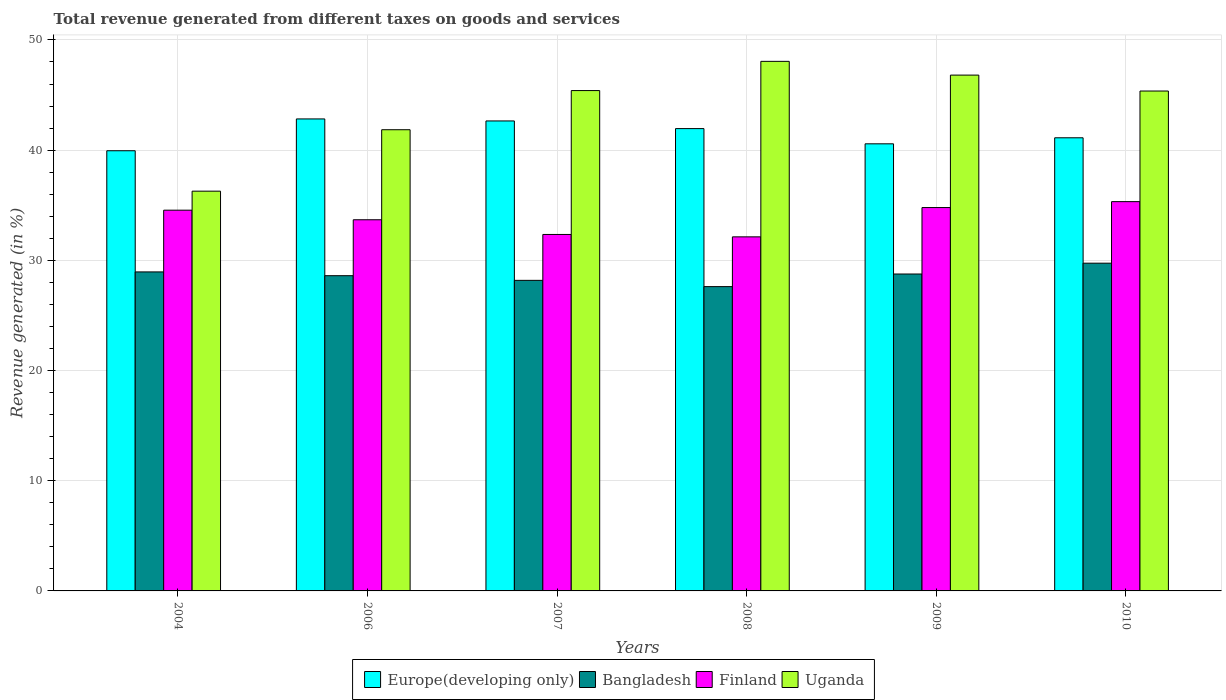How many different coloured bars are there?
Provide a succinct answer. 4. How many groups of bars are there?
Offer a very short reply. 6. Are the number of bars per tick equal to the number of legend labels?
Give a very brief answer. Yes. What is the label of the 5th group of bars from the left?
Your response must be concise. 2009. In how many cases, is the number of bars for a given year not equal to the number of legend labels?
Make the answer very short. 0. What is the total revenue generated in Europe(developing only) in 2010?
Provide a short and direct response. 41.12. Across all years, what is the maximum total revenue generated in Bangladesh?
Give a very brief answer. 29.74. Across all years, what is the minimum total revenue generated in Bangladesh?
Your answer should be very brief. 27.61. In which year was the total revenue generated in Uganda maximum?
Make the answer very short. 2008. What is the total total revenue generated in Europe(developing only) in the graph?
Your answer should be compact. 249.07. What is the difference between the total revenue generated in Uganda in 2004 and that in 2010?
Keep it short and to the point. -9.09. What is the difference between the total revenue generated in Bangladesh in 2010 and the total revenue generated in Europe(developing only) in 2006?
Your answer should be very brief. -13.09. What is the average total revenue generated in Europe(developing only) per year?
Ensure brevity in your answer.  41.51. In the year 2010, what is the difference between the total revenue generated in Bangladesh and total revenue generated in Europe(developing only)?
Ensure brevity in your answer.  -11.38. What is the ratio of the total revenue generated in Europe(developing only) in 2004 to that in 2010?
Your answer should be very brief. 0.97. What is the difference between the highest and the second highest total revenue generated in Uganda?
Ensure brevity in your answer.  1.25. What is the difference between the highest and the lowest total revenue generated in Europe(developing only)?
Keep it short and to the point. 2.89. Is the sum of the total revenue generated in Bangladesh in 2004 and 2008 greater than the maximum total revenue generated in Uganda across all years?
Give a very brief answer. Yes. Is it the case that in every year, the sum of the total revenue generated in Bangladesh and total revenue generated in Finland is greater than the sum of total revenue generated in Europe(developing only) and total revenue generated in Uganda?
Ensure brevity in your answer.  No. What does the 2nd bar from the left in 2007 represents?
Offer a very short reply. Bangladesh. What does the 1st bar from the right in 2008 represents?
Keep it short and to the point. Uganda. Is it the case that in every year, the sum of the total revenue generated in Europe(developing only) and total revenue generated in Bangladesh is greater than the total revenue generated in Uganda?
Make the answer very short. Yes. How many bars are there?
Your answer should be very brief. 24. How many years are there in the graph?
Your answer should be compact. 6. Does the graph contain any zero values?
Keep it short and to the point. No. Does the graph contain grids?
Ensure brevity in your answer.  Yes. What is the title of the graph?
Provide a short and direct response. Total revenue generated from different taxes on goods and services. What is the label or title of the Y-axis?
Offer a terse response. Revenue generated (in %). What is the Revenue generated (in %) of Europe(developing only) in 2004?
Your answer should be very brief. 39.94. What is the Revenue generated (in %) in Bangladesh in 2004?
Give a very brief answer. 28.95. What is the Revenue generated (in %) of Finland in 2004?
Offer a very short reply. 34.55. What is the Revenue generated (in %) in Uganda in 2004?
Keep it short and to the point. 36.28. What is the Revenue generated (in %) in Europe(developing only) in 2006?
Ensure brevity in your answer.  42.83. What is the Revenue generated (in %) of Bangladesh in 2006?
Provide a short and direct response. 28.61. What is the Revenue generated (in %) of Finland in 2006?
Offer a very short reply. 33.68. What is the Revenue generated (in %) of Uganda in 2006?
Offer a terse response. 41.85. What is the Revenue generated (in %) in Europe(developing only) in 2007?
Your response must be concise. 42.65. What is the Revenue generated (in %) of Bangladesh in 2007?
Your answer should be compact. 28.18. What is the Revenue generated (in %) of Finland in 2007?
Offer a very short reply. 32.35. What is the Revenue generated (in %) in Uganda in 2007?
Offer a very short reply. 45.4. What is the Revenue generated (in %) of Europe(developing only) in 2008?
Offer a terse response. 41.95. What is the Revenue generated (in %) of Bangladesh in 2008?
Provide a short and direct response. 27.61. What is the Revenue generated (in %) in Finland in 2008?
Offer a terse response. 32.13. What is the Revenue generated (in %) in Uganda in 2008?
Keep it short and to the point. 48.06. What is the Revenue generated (in %) in Europe(developing only) in 2009?
Provide a succinct answer. 40.57. What is the Revenue generated (in %) in Bangladesh in 2009?
Ensure brevity in your answer.  28.76. What is the Revenue generated (in %) of Finland in 2009?
Your response must be concise. 34.79. What is the Revenue generated (in %) of Uganda in 2009?
Provide a succinct answer. 46.81. What is the Revenue generated (in %) of Europe(developing only) in 2010?
Provide a succinct answer. 41.12. What is the Revenue generated (in %) in Bangladesh in 2010?
Your answer should be compact. 29.74. What is the Revenue generated (in %) in Finland in 2010?
Offer a terse response. 35.33. What is the Revenue generated (in %) in Uganda in 2010?
Provide a succinct answer. 45.36. Across all years, what is the maximum Revenue generated (in %) in Europe(developing only)?
Provide a short and direct response. 42.83. Across all years, what is the maximum Revenue generated (in %) of Bangladesh?
Offer a very short reply. 29.74. Across all years, what is the maximum Revenue generated (in %) in Finland?
Provide a succinct answer. 35.33. Across all years, what is the maximum Revenue generated (in %) in Uganda?
Your answer should be very brief. 48.06. Across all years, what is the minimum Revenue generated (in %) in Europe(developing only)?
Ensure brevity in your answer.  39.94. Across all years, what is the minimum Revenue generated (in %) in Bangladesh?
Ensure brevity in your answer.  27.61. Across all years, what is the minimum Revenue generated (in %) in Finland?
Your answer should be very brief. 32.13. Across all years, what is the minimum Revenue generated (in %) of Uganda?
Offer a terse response. 36.28. What is the total Revenue generated (in %) of Europe(developing only) in the graph?
Give a very brief answer. 249.07. What is the total Revenue generated (in %) in Bangladesh in the graph?
Ensure brevity in your answer.  171.85. What is the total Revenue generated (in %) in Finland in the graph?
Provide a succinct answer. 202.82. What is the total Revenue generated (in %) of Uganda in the graph?
Give a very brief answer. 263.76. What is the difference between the Revenue generated (in %) in Europe(developing only) in 2004 and that in 2006?
Your response must be concise. -2.89. What is the difference between the Revenue generated (in %) in Bangladesh in 2004 and that in 2006?
Your answer should be very brief. 0.34. What is the difference between the Revenue generated (in %) of Finland in 2004 and that in 2006?
Your answer should be very brief. 0.87. What is the difference between the Revenue generated (in %) in Uganda in 2004 and that in 2006?
Offer a terse response. -5.58. What is the difference between the Revenue generated (in %) of Europe(developing only) in 2004 and that in 2007?
Provide a succinct answer. -2.7. What is the difference between the Revenue generated (in %) of Bangladesh in 2004 and that in 2007?
Offer a terse response. 0.77. What is the difference between the Revenue generated (in %) of Finland in 2004 and that in 2007?
Your response must be concise. 2.2. What is the difference between the Revenue generated (in %) of Uganda in 2004 and that in 2007?
Provide a succinct answer. -9.13. What is the difference between the Revenue generated (in %) of Europe(developing only) in 2004 and that in 2008?
Provide a succinct answer. -2.01. What is the difference between the Revenue generated (in %) in Bangladesh in 2004 and that in 2008?
Give a very brief answer. 1.33. What is the difference between the Revenue generated (in %) in Finland in 2004 and that in 2008?
Provide a succinct answer. 2.42. What is the difference between the Revenue generated (in %) of Uganda in 2004 and that in 2008?
Keep it short and to the point. -11.78. What is the difference between the Revenue generated (in %) of Europe(developing only) in 2004 and that in 2009?
Give a very brief answer. -0.63. What is the difference between the Revenue generated (in %) in Bangladesh in 2004 and that in 2009?
Make the answer very short. 0.19. What is the difference between the Revenue generated (in %) of Finland in 2004 and that in 2009?
Give a very brief answer. -0.24. What is the difference between the Revenue generated (in %) of Uganda in 2004 and that in 2009?
Your answer should be compact. -10.53. What is the difference between the Revenue generated (in %) of Europe(developing only) in 2004 and that in 2010?
Offer a very short reply. -1.18. What is the difference between the Revenue generated (in %) of Bangladesh in 2004 and that in 2010?
Give a very brief answer. -0.79. What is the difference between the Revenue generated (in %) in Finland in 2004 and that in 2010?
Your response must be concise. -0.78. What is the difference between the Revenue generated (in %) of Uganda in 2004 and that in 2010?
Offer a terse response. -9.09. What is the difference between the Revenue generated (in %) in Europe(developing only) in 2006 and that in 2007?
Your response must be concise. 0.18. What is the difference between the Revenue generated (in %) of Bangladesh in 2006 and that in 2007?
Offer a terse response. 0.42. What is the difference between the Revenue generated (in %) in Finland in 2006 and that in 2007?
Provide a succinct answer. 1.33. What is the difference between the Revenue generated (in %) in Uganda in 2006 and that in 2007?
Make the answer very short. -3.55. What is the difference between the Revenue generated (in %) of Europe(developing only) in 2006 and that in 2008?
Give a very brief answer. 0.88. What is the difference between the Revenue generated (in %) of Bangladesh in 2006 and that in 2008?
Your response must be concise. 0.99. What is the difference between the Revenue generated (in %) in Finland in 2006 and that in 2008?
Offer a very short reply. 1.55. What is the difference between the Revenue generated (in %) of Uganda in 2006 and that in 2008?
Your answer should be compact. -6.2. What is the difference between the Revenue generated (in %) in Europe(developing only) in 2006 and that in 2009?
Keep it short and to the point. 2.26. What is the difference between the Revenue generated (in %) in Bangladesh in 2006 and that in 2009?
Keep it short and to the point. -0.15. What is the difference between the Revenue generated (in %) of Finland in 2006 and that in 2009?
Ensure brevity in your answer.  -1.11. What is the difference between the Revenue generated (in %) in Uganda in 2006 and that in 2009?
Provide a short and direct response. -4.96. What is the difference between the Revenue generated (in %) in Europe(developing only) in 2006 and that in 2010?
Give a very brief answer. 1.71. What is the difference between the Revenue generated (in %) of Bangladesh in 2006 and that in 2010?
Give a very brief answer. -1.14. What is the difference between the Revenue generated (in %) in Finland in 2006 and that in 2010?
Your response must be concise. -1.64. What is the difference between the Revenue generated (in %) of Uganda in 2006 and that in 2010?
Your answer should be very brief. -3.51. What is the difference between the Revenue generated (in %) of Europe(developing only) in 2007 and that in 2008?
Give a very brief answer. 0.69. What is the difference between the Revenue generated (in %) in Bangladesh in 2007 and that in 2008?
Offer a terse response. 0.57. What is the difference between the Revenue generated (in %) in Finland in 2007 and that in 2008?
Your answer should be compact. 0.22. What is the difference between the Revenue generated (in %) of Uganda in 2007 and that in 2008?
Your answer should be compact. -2.65. What is the difference between the Revenue generated (in %) of Europe(developing only) in 2007 and that in 2009?
Offer a terse response. 2.08. What is the difference between the Revenue generated (in %) of Bangladesh in 2007 and that in 2009?
Your response must be concise. -0.58. What is the difference between the Revenue generated (in %) in Finland in 2007 and that in 2009?
Your answer should be very brief. -2.44. What is the difference between the Revenue generated (in %) of Uganda in 2007 and that in 2009?
Your answer should be compact. -1.4. What is the difference between the Revenue generated (in %) of Europe(developing only) in 2007 and that in 2010?
Make the answer very short. 1.53. What is the difference between the Revenue generated (in %) of Bangladesh in 2007 and that in 2010?
Provide a short and direct response. -1.56. What is the difference between the Revenue generated (in %) of Finland in 2007 and that in 2010?
Your answer should be compact. -2.98. What is the difference between the Revenue generated (in %) of Uganda in 2007 and that in 2010?
Keep it short and to the point. 0.04. What is the difference between the Revenue generated (in %) of Europe(developing only) in 2008 and that in 2009?
Keep it short and to the point. 1.38. What is the difference between the Revenue generated (in %) in Bangladesh in 2008 and that in 2009?
Make the answer very short. -1.14. What is the difference between the Revenue generated (in %) in Finland in 2008 and that in 2009?
Provide a succinct answer. -2.66. What is the difference between the Revenue generated (in %) of Uganda in 2008 and that in 2009?
Provide a short and direct response. 1.25. What is the difference between the Revenue generated (in %) in Europe(developing only) in 2008 and that in 2010?
Make the answer very short. 0.83. What is the difference between the Revenue generated (in %) of Bangladesh in 2008 and that in 2010?
Offer a very short reply. -2.13. What is the difference between the Revenue generated (in %) in Finland in 2008 and that in 2010?
Your answer should be compact. -3.2. What is the difference between the Revenue generated (in %) in Uganda in 2008 and that in 2010?
Ensure brevity in your answer.  2.69. What is the difference between the Revenue generated (in %) of Europe(developing only) in 2009 and that in 2010?
Keep it short and to the point. -0.55. What is the difference between the Revenue generated (in %) in Bangladesh in 2009 and that in 2010?
Provide a short and direct response. -0.98. What is the difference between the Revenue generated (in %) in Finland in 2009 and that in 2010?
Make the answer very short. -0.54. What is the difference between the Revenue generated (in %) of Uganda in 2009 and that in 2010?
Your answer should be very brief. 1.44. What is the difference between the Revenue generated (in %) of Europe(developing only) in 2004 and the Revenue generated (in %) of Bangladesh in 2006?
Provide a short and direct response. 11.34. What is the difference between the Revenue generated (in %) of Europe(developing only) in 2004 and the Revenue generated (in %) of Finland in 2006?
Provide a short and direct response. 6.26. What is the difference between the Revenue generated (in %) of Europe(developing only) in 2004 and the Revenue generated (in %) of Uganda in 2006?
Ensure brevity in your answer.  -1.91. What is the difference between the Revenue generated (in %) in Bangladesh in 2004 and the Revenue generated (in %) in Finland in 2006?
Make the answer very short. -4.73. What is the difference between the Revenue generated (in %) of Bangladesh in 2004 and the Revenue generated (in %) of Uganda in 2006?
Your answer should be compact. -12.9. What is the difference between the Revenue generated (in %) of Finland in 2004 and the Revenue generated (in %) of Uganda in 2006?
Your answer should be compact. -7.3. What is the difference between the Revenue generated (in %) in Europe(developing only) in 2004 and the Revenue generated (in %) in Bangladesh in 2007?
Offer a terse response. 11.76. What is the difference between the Revenue generated (in %) of Europe(developing only) in 2004 and the Revenue generated (in %) of Finland in 2007?
Offer a very short reply. 7.6. What is the difference between the Revenue generated (in %) in Europe(developing only) in 2004 and the Revenue generated (in %) in Uganda in 2007?
Offer a terse response. -5.46. What is the difference between the Revenue generated (in %) of Bangladesh in 2004 and the Revenue generated (in %) of Finland in 2007?
Provide a short and direct response. -3.4. What is the difference between the Revenue generated (in %) in Bangladesh in 2004 and the Revenue generated (in %) in Uganda in 2007?
Your answer should be compact. -16.46. What is the difference between the Revenue generated (in %) in Finland in 2004 and the Revenue generated (in %) in Uganda in 2007?
Offer a terse response. -10.85. What is the difference between the Revenue generated (in %) in Europe(developing only) in 2004 and the Revenue generated (in %) in Bangladesh in 2008?
Make the answer very short. 12.33. What is the difference between the Revenue generated (in %) in Europe(developing only) in 2004 and the Revenue generated (in %) in Finland in 2008?
Your response must be concise. 7.81. What is the difference between the Revenue generated (in %) in Europe(developing only) in 2004 and the Revenue generated (in %) in Uganda in 2008?
Provide a succinct answer. -8.11. What is the difference between the Revenue generated (in %) of Bangladesh in 2004 and the Revenue generated (in %) of Finland in 2008?
Keep it short and to the point. -3.18. What is the difference between the Revenue generated (in %) in Bangladesh in 2004 and the Revenue generated (in %) in Uganda in 2008?
Give a very brief answer. -19.11. What is the difference between the Revenue generated (in %) of Finland in 2004 and the Revenue generated (in %) of Uganda in 2008?
Make the answer very short. -13.5. What is the difference between the Revenue generated (in %) of Europe(developing only) in 2004 and the Revenue generated (in %) of Bangladesh in 2009?
Your answer should be very brief. 11.19. What is the difference between the Revenue generated (in %) of Europe(developing only) in 2004 and the Revenue generated (in %) of Finland in 2009?
Offer a very short reply. 5.16. What is the difference between the Revenue generated (in %) of Europe(developing only) in 2004 and the Revenue generated (in %) of Uganda in 2009?
Provide a succinct answer. -6.86. What is the difference between the Revenue generated (in %) of Bangladesh in 2004 and the Revenue generated (in %) of Finland in 2009?
Provide a short and direct response. -5.84. What is the difference between the Revenue generated (in %) in Bangladesh in 2004 and the Revenue generated (in %) in Uganda in 2009?
Offer a very short reply. -17.86. What is the difference between the Revenue generated (in %) of Finland in 2004 and the Revenue generated (in %) of Uganda in 2009?
Keep it short and to the point. -12.26. What is the difference between the Revenue generated (in %) of Europe(developing only) in 2004 and the Revenue generated (in %) of Bangladesh in 2010?
Your answer should be very brief. 10.2. What is the difference between the Revenue generated (in %) in Europe(developing only) in 2004 and the Revenue generated (in %) in Finland in 2010?
Your response must be concise. 4.62. What is the difference between the Revenue generated (in %) in Europe(developing only) in 2004 and the Revenue generated (in %) in Uganda in 2010?
Provide a succinct answer. -5.42. What is the difference between the Revenue generated (in %) in Bangladesh in 2004 and the Revenue generated (in %) in Finland in 2010?
Offer a terse response. -6.38. What is the difference between the Revenue generated (in %) of Bangladesh in 2004 and the Revenue generated (in %) of Uganda in 2010?
Offer a terse response. -16.42. What is the difference between the Revenue generated (in %) of Finland in 2004 and the Revenue generated (in %) of Uganda in 2010?
Ensure brevity in your answer.  -10.81. What is the difference between the Revenue generated (in %) of Europe(developing only) in 2006 and the Revenue generated (in %) of Bangladesh in 2007?
Make the answer very short. 14.65. What is the difference between the Revenue generated (in %) of Europe(developing only) in 2006 and the Revenue generated (in %) of Finland in 2007?
Provide a short and direct response. 10.48. What is the difference between the Revenue generated (in %) in Europe(developing only) in 2006 and the Revenue generated (in %) in Uganda in 2007?
Your answer should be very brief. -2.57. What is the difference between the Revenue generated (in %) of Bangladesh in 2006 and the Revenue generated (in %) of Finland in 2007?
Offer a terse response. -3.74. What is the difference between the Revenue generated (in %) of Bangladesh in 2006 and the Revenue generated (in %) of Uganda in 2007?
Your response must be concise. -16.8. What is the difference between the Revenue generated (in %) in Finland in 2006 and the Revenue generated (in %) in Uganda in 2007?
Offer a very short reply. -11.72. What is the difference between the Revenue generated (in %) of Europe(developing only) in 2006 and the Revenue generated (in %) of Bangladesh in 2008?
Your response must be concise. 15.22. What is the difference between the Revenue generated (in %) in Europe(developing only) in 2006 and the Revenue generated (in %) in Finland in 2008?
Provide a short and direct response. 10.7. What is the difference between the Revenue generated (in %) in Europe(developing only) in 2006 and the Revenue generated (in %) in Uganda in 2008?
Offer a very short reply. -5.23. What is the difference between the Revenue generated (in %) in Bangladesh in 2006 and the Revenue generated (in %) in Finland in 2008?
Make the answer very short. -3.52. What is the difference between the Revenue generated (in %) of Bangladesh in 2006 and the Revenue generated (in %) of Uganda in 2008?
Your answer should be compact. -19.45. What is the difference between the Revenue generated (in %) of Finland in 2006 and the Revenue generated (in %) of Uganda in 2008?
Offer a terse response. -14.37. What is the difference between the Revenue generated (in %) of Europe(developing only) in 2006 and the Revenue generated (in %) of Bangladesh in 2009?
Your answer should be very brief. 14.07. What is the difference between the Revenue generated (in %) in Europe(developing only) in 2006 and the Revenue generated (in %) in Finland in 2009?
Ensure brevity in your answer.  8.04. What is the difference between the Revenue generated (in %) in Europe(developing only) in 2006 and the Revenue generated (in %) in Uganda in 2009?
Your response must be concise. -3.98. What is the difference between the Revenue generated (in %) of Bangladesh in 2006 and the Revenue generated (in %) of Finland in 2009?
Keep it short and to the point. -6.18. What is the difference between the Revenue generated (in %) in Bangladesh in 2006 and the Revenue generated (in %) in Uganda in 2009?
Keep it short and to the point. -18.2. What is the difference between the Revenue generated (in %) of Finland in 2006 and the Revenue generated (in %) of Uganda in 2009?
Provide a short and direct response. -13.13. What is the difference between the Revenue generated (in %) of Europe(developing only) in 2006 and the Revenue generated (in %) of Bangladesh in 2010?
Offer a very short reply. 13.09. What is the difference between the Revenue generated (in %) of Europe(developing only) in 2006 and the Revenue generated (in %) of Finland in 2010?
Provide a succinct answer. 7.5. What is the difference between the Revenue generated (in %) of Europe(developing only) in 2006 and the Revenue generated (in %) of Uganda in 2010?
Provide a succinct answer. -2.53. What is the difference between the Revenue generated (in %) in Bangladesh in 2006 and the Revenue generated (in %) in Finland in 2010?
Ensure brevity in your answer.  -6.72. What is the difference between the Revenue generated (in %) in Bangladesh in 2006 and the Revenue generated (in %) in Uganda in 2010?
Your response must be concise. -16.76. What is the difference between the Revenue generated (in %) of Finland in 2006 and the Revenue generated (in %) of Uganda in 2010?
Offer a very short reply. -11.68. What is the difference between the Revenue generated (in %) in Europe(developing only) in 2007 and the Revenue generated (in %) in Bangladesh in 2008?
Your answer should be very brief. 15.03. What is the difference between the Revenue generated (in %) of Europe(developing only) in 2007 and the Revenue generated (in %) of Finland in 2008?
Ensure brevity in your answer.  10.52. What is the difference between the Revenue generated (in %) of Europe(developing only) in 2007 and the Revenue generated (in %) of Uganda in 2008?
Offer a very short reply. -5.41. What is the difference between the Revenue generated (in %) in Bangladesh in 2007 and the Revenue generated (in %) in Finland in 2008?
Keep it short and to the point. -3.95. What is the difference between the Revenue generated (in %) of Bangladesh in 2007 and the Revenue generated (in %) of Uganda in 2008?
Give a very brief answer. -19.87. What is the difference between the Revenue generated (in %) in Finland in 2007 and the Revenue generated (in %) in Uganda in 2008?
Your response must be concise. -15.71. What is the difference between the Revenue generated (in %) in Europe(developing only) in 2007 and the Revenue generated (in %) in Bangladesh in 2009?
Offer a terse response. 13.89. What is the difference between the Revenue generated (in %) of Europe(developing only) in 2007 and the Revenue generated (in %) of Finland in 2009?
Keep it short and to the point. 7.86. What is the difference between the Revenue generated (in %) of Europe(developing only) in 2007 and the Revenue generated (in %) of Uganda in 2009?
Ensure brevity in your answer.  -4.16. What is the difference between the Revenue generated (in %) in Bangladesh in 2007 and the Revenue generated (in %) in Finland in 2009?
Make the answer very short. -6.61. What is the difference between the Revenue generated (in %) in Bangladesh in 2007 and the Revenue generated (in %) in Uganda in 2009?
Your response must be concise. -18.63. What is the difference between the Revenue generated (in %) of Finland in 2007 and the Revenue generated (in %) of Uganda in 2009?
Ensure brevity in your answer.  -14.46. What is the difference between the Revenue generated (in %) in Europe(developing only) in 2007 and the Revenue generated (in %) in Bangladesh in 2010?
Your response must be concise. 12.91. What is the difference between the Revenue generated (in %) of Europe(developing only) in 2007 and the Revenue generated (in %) of Finland in 2010?
Provide a short and direct response. 7.32. What is the difference between the Revenue generated (in %) of Europe(developing only) in 2007 and the Revenue generated (in %) of Uganda in 2010?
Ensure brevity in your answer.  -2.72. What is the difference between the Revenue generated (in %) of Bangladesh in 2007 and the Revenue generated (in %) of Finland in 2010?
Your answer should be very brief. -7.14. What is the difference between the Revenue generated (in %) of Bangladesh in 2007 and the Revenue generated (in %) of Uganda in 2010?
Offer a terse response. -17.18. What is the difference between the Revenue generated (in %) in Finland in 2007 and the Revenue generated (in %) in Uganda in 2010?
Give a very brief answer. -13.02. What is the difference between the Revenue generated (in %) in Europe(developing only) in 2008 and the Revenue generated (in %) in Bangladesh in 2009?
Ensure brevity in your answer.  13.2. What is the difference between the Revenue generated (in %) of Europe(developing only) in 2008 and the Revenue generated (in %) of Finland in 2009?
Make the answer very short. 7.17. What is the difference between the Revenue generated (in %) in Europe(developing only) in 2008 and the Revenue generated (in %) in Uganda in 2009?
Provide a short and direct response. -4.85. What is the difference between the Revenue generated (in %) in Bangladesh in 2008 and the Revenue generated (in %) in Finland in 2009?
Offer a very short reply. -7.17. What is the difference between the Revenue generated (in %) in Bangladesh in 2008 and the Revenue generated (in %) in Uganda in 2009?
Offer a very short reply. -19.19. What is the difference between the Revenue generated (in %) of Finland in 2008 and the Revenue generated (in %) of Uganda in 2009?
Your response must be concise. -14.68. What is the difference between the Revenue generated (in %) of Europe(developing only) in 2008 and the Revenue generated (in %) of Bangladesh in 2010?
Provide a short and direct response. 12.21. What is the difference between the Revenue generated (in %) in Europe(developing only) in 2008 and the Revenue generated (in %) in Finland in 2010?
Your response must be concise. 6.63. What is the difference between the Revenue generated (in %) of Europe(developing only) in 2008 and the Revenue generated (in %) of Uganda in 2010?
Your response must be concise. -3.41. What is the difference between the Revenue generated (in %) of Bangladesh in 2008 and the Revenue generated (in %) of Finland in 2010?
Your response must be concise. -7.71. What is the difference between the Revenue generated (in %) in Bangladesh in 2008 and the Revenue generated (in %) in Uganda in 2010?
Your response must be concise. -17.75. What is the difference between the Revenue generated (in %) of Finland in 2008 and the Revenue generated (in %) of Uganda in 2010?
Your response must be concise. -13.23. What is the difference between the Revenue generated (in %) in Europe(developing only) in 2009 and the Revenue generated (in %) in Bangladesh in 2010?
Keep it short and to the point. 10.83. What is the difference between the Revenue generated (in %) in Europe(developing only) in 2009 and the Revenue generated (in %) in Finland in 2010?
Your answer should be compact. 5.25. What is the difference between the Revenue generated (in %) in Europe(developing only) in 2009 and the Revenue generated (in %) in Uganda in 2010?
Offer a very short reply. -4.79. What is the difference between the Revenue generated (in %) in Bangladesh in 2009 and the Revenue generated (in %) in Finland in 2010?
Keep it short and to the point. -6.57. What is the difference between the Revenue generated (in %) in Bangladesh in 2009 and the Revenue generated (in %) in Uganda in 2010?
Offer a terse response. -16.61. What is the difference between the Revenue generated (in %) in Finland in 2009 and the Revenue generated (in %) in Uganda in 2010?
Offer a very short reply. -10.58. What is the average Revenue generated (in %) of Europe(developing only) per year?
Make the answer very short. 41.51. What is the average Revenue generated (in %) in Bangladesh per year?
Offer a very short reply. 28.64. What is the average Revenue generated (in %) of Finland per year?
Provide a succinct answer. 33.8. What is the average Revenue generated (in %) in Uganda per year?
Your response must be concise. 43.96. In the year 2004, what is the difference between the Revenue generated (in %) of Europe(developing only) and Revenue generated (in %) of Bangladesh?
Your response must be concise. 11. In the year 2004, what is the difference between the Revenue generated (in %) in Europe(developing only) and Revenue generated (in %) in Finland?
Make the answer very short. 5.39. In the year 2004, what is the difference between the Revenue generated (in %) of Europe(developing only) and Revenue generated (in %) of Uganda?
Your answer should be compact. 3.67. In the year 2004, what is the difference between the Revenue generated (in %) of Bangladesh and Revenue generated (in %) of Finland?
Ensure brevity in your answer.  -5.6. In the year 2004, what is the difference between the Revenue generated (in %) of Bangladesh and Revenue generated (in %) of Uganda?
Your response must be concise. -7.33. In the year 2004, what is the difference between the Revenue generated (in %) in Finland and Revenue generated (in %) in Uganda?
Keep it short and to the point. -1.72. In the year 2006, what is the difference between the Revenue generated (in %) of Europe(developing only) and Revenue generated (in %) of Bangladesh?
Offer a terse response. 14.22. In the year 2006, what is the difference between the Revenue generated (in %) of Europe(developing only) and Revenue generated (in %) of Finland?
Keep it short and to the point. 9.15. In the year 2006, what is the difference between the Revenue generated (in %) of Europe(developing only) and Revenue generated (in %) of Uganda?
Offer a terse response. 0.98. In the year 2006, what is the difference between the Revenue generated (in %) of Bangladesh and Revenue generated (in %) of Finland?
Make the answer very short. -5.08. In the year 2006, what is the difference between the Revenue generated (in %) of Bangladesh and Revenue generated (in %) of Uganda?
Ensure brevity in your answer.  -13.25. In the year 2006, what is the difference between the Revenue generated (in %) of Finland and Revenue generated (in %) of Uganda?
Give a very brief answer. -8.17. In the year 2007, what is the difference between the Revenue generated (in %) of Europe(developing only) and Revenue generated (in %) of Bangladesh?
Your answer should be compact. 14.47. In the year 2007, what is the difference between the Revenue generated (in %) of Europe(developing only) and Revenue generated (in %) of Finland?
Offer a very short reply. 10.3. In the year 2007, what is the difference between the Revenue generated (in %) in Europe(developing only) and Revenue generated (in %) in Uganda?
Provide a short and direct response. -2.76. In the year 2007, what is the difference between the Revenue generated (in %) of Bangladesh and Revenue generated (in %) of Finland?
Your answer should be compact. -4.16. In the year 2007, what is the difference between the Revenue generated (in %) of Bangladesh and Revenue generated (in %) of Uganda?
Make the answer very short. -17.22. In the year 2007, what is the difference between the Revenue generated (in %) of Finland and Revenue generated (in %) of Uganda?
Give a very brief answer. -13.06. In the year 2008, what is the difference between the Revenue generated (in %) in Europe(developing only) and Revenue generated (in %) in Bangladesh?
Ensure brevity in your answer.  14.34. In the year 2008, what is the difference between the Revenue generated (in %) in Europe(developing only) and Revenue generated (in %) in Finland?
Give a very brief answer. 9.82. In the year 2008, what is the difference between the Revenue generated (in %) of Europe(developing only) and Revenue generated (in %) of Uganda?
Give a very brief answer. -6.1. In the year 2008, what is the difference between the Revenue generated (in %) in Bangladesh and Revenue generated (in %) in Finland?
Make the answer very short. -4.52. In the year 2008, what is the difference between the Revenue generated (in %) of Bangladesh and Revenue generated (in %) of Uganda?
Provide a short and direct response. -20.44. In the year 2008, what is the difference between the Revenue generated (in %) of Finland and Revenue generated (in %) of Uganda?
Keep it short and to the point. -15.93. In the year 2009, what is the difference between the Revenue generated (in %) in Europe(developing only) and Revenue generated (in %) in Bangladesh?
Offer a very short reply. 11.81. In the year 2009, what is the difference between the Revenue generated (in %) in Europe(developing only) and Revenue generated (in %) in Finland?
Your answer should be very brief. 5.78. In the year 2009, what is the difference between the Revenue generated (in %) in Europe(developing only) and Revenue generated (in %) in Uganda?
Offer a terse response. -6.24. In the year 2009, what is the difference between the Revenue generated (in %) of Bangladesh and Revenue generated (in %) of Finland?
Provide a short and direct response. -6.03. In the year 2009, what is the difference between the Revenue generated (in %) in Bangladesh and Revenue generated (in %) in Uganda?
Your answer should be compact. -18.05. In the year 2009, what is the difference between the Revenue generated (in %) in Finland and Revenue generated (in %) in Uganda?
Ensure brevity in your answer.  -12.02. In the year 2010, what is the difference between the Revenue generated (in %) in Europe(developing only) and Revenue generated (in %) in Bangladesh?
Provide a short and direct response. 11.38. In the year 2010, what is the difference between the Revenue generated (in %) in Europe(developing only) and Revenue generated (in %) in Finland?
Offer a terse response. 5.79. In the year 2010, what is the difference between the Revenue generated (in %) in Europe(developing only) and Revenue generated (in %) in Uganda?
Provide a short and direct response. -4.24. In the year 2010, what is the difference between the Revenue generated (in %) in Bangladesh and Revenue generated (in %) in Finland?
Offer a very short reply. -5.58. In the year 2010, what is the difference between the Revenue generated (in %) in Bangladesh and Revenue generated (in %) in Uganda?
Ensure brevity in your answer.  -15.62. In the year 2010, what is the difference between the Revenue generated (in %) of Finland and Revenue generated (in %) of Uganda?
Offer a very short reply. -10.04. What is the ratio of the Revenue generated (in %) of Europe(developing only) in 2004 to that in 2006?
Keep it short and to the point. 0.93. What is the ratio of the Revenue generated (in %) in Bangladesh in 2004 to that in 2006?
Provide a succinct answer. 1.01. What is the ratio of the Revenue generated (in %) of Finland in 2004 to that in 2006?
Keep it short and to the point. 1.03. What is the ratio of the Revenue generated (in %) in Uganda in 2004 to that in 2006?
Your answer should be very brief. 0.87. What is the ratio of the Revenue generated (in %) in Europe(developing only) in 2004 to that in 2007?
Offer a very short reply. 0.94. What is the ratio of the Revenue generated (in %) in Bangladesh in 2004 to that in 2007?
Your answer should be compact. 1.03. What is the ratio of the Revenue generated (in %) in Finland in 2004 to that in 2007?
Provide a short and direct response. 1.07. What is the ratio of the Revenue generated (in %) of Uganda in 2004 to that in 2007?
Offer a very short reply. 0.8. What is the ratio of the Revenue generated (in %) of Europe(developing only) in 2004 to that in 2008?
Offer a very short reply. 0.95. What is the ratio of the Revenue generated (in %) in Bangladesh in 2004 to that in 2008?
Offer a terse response. 1.05. What is the ratio of the Revenue generated (in %) of Finland in 2004 to that in 2008?
Keep it short and to the point. 1.08. What is the ratio of the Revenue generated (in %) of Uganda in 2004 to that in 2008?
Your answer should be very brief. 0.75. What is the ratio of the Revenue generated (in %) of Europe(developing only) in 2004 to that in 2009?
Offer a terse response. 0.98. What is the ratio of the Revenue generated (in %) of Bangladesh in 2004 to that in 2009?
Ensure brevity in your answer.  1.01. What is the ratio of the Revenue generated (in %) in Finland in 2004 to that in 2009?
Give a very brief answer. 0.99. What is the ratio of the Revenue generated (in %) of Uganda in 2004 to that in 2009?
Your answer should be very brief. 0.78. What is the ratio of the Revenue generated (in %) in Europe(developing only) in 2004 to that in 2010?
Ensure brevity in your answer.  0.97. What is the ratio of the Revenue generated (in %) of Bangladesh in 2004 to that in 2010?
Offer a very short reply. 0.97. What is the ratio of the Revenue generated (in %) of Finland in 2004 to that in 2010?
Provide a succinct answer. 0.98. What is the ratio of the Revenue generated (in %) of Uganda in 2004 to that in 2010?
Your answer should be very brief. 0.8. What is the ratio of the Revenue generated (in %) of Europe(developing only) in 2006 to that in 2007?
Offer a terse response. 1. What is the ratio of the Revenue generated (in %) in Bangladesh in 2006 to that in 2007?
Your response must be concise. 1.01. What is the ratio of the Revenue generated (in %) in Finland in 2006 to that in 2007?
Your answer should be compact. 1.04. What is the ratio of the Revenue generated (in %) in Uganda in 2006 to that in 2007?
Your response must be concise. 0.92. What is the ratio of the Revenue generated (in %) in Europe(developing only) in 2006 to that in 2008?
Provide a short and direct response. 1.02. What is the ratio of the Revenue generated (in %) of Bangladesh in 2006 to that in 2008?
Provide a short and direct response. 1.04. What is the ratio of the Revenue generated (in %) of Finland in 2006 to that in 2008?
Your response must be concise. 1.05. What is the ratio of the Revenue generated (in %) of Uganda in 2006 to that in 2008?
Your answer should be very brief. 0.87. What is the ratio of the Revenue generated (in %) of Europe(developing only) in 2006 to that in 2009?
Provide a short and direct response. 1.06. What is the ratio of the Revenue generated (in %) of Bangladesh in 2006 to that in 2009?
Your response must be concise. 0.99. What is the ratio of the Revenue generated (in %) of Finland in 2006 to that in 2009?
Your response must be concise. 0.97. What is the ratio of the Revenue generated (in %) in Uganda in 2006 to that in 2009?
Provide a short and direct response. 0.89. What is the ratio of the Revenue generated (in %) in Europe(developing only) in 2006 to that in 2010?
Make the answer very short. 1.04. What is the ratio of the Revenue generated (in %) of Bangladesh in 2006 to that in 2010?
Ensure brevity in your answer.  0.96. What is the ratio of the Revenue generated (in %) of Finland in 2006 to that in 2010?
Provide a short and direct response. 0.95. What is the ratio of the Revenue generated (in %) of Uganda in 2006 to that in 2010?
Your response must be concise. 0.92. What is the ratio of the Revenue generated (in %) in Europe(developing only) in 2007 to that in 2008?
Make the answer very short. 1.02. What is the ratio of the Revenue generated (in %) of Bangladesh in 2007 to that in 2008?
Offer a very short reply. 1.02. What is the ratio of the Revenue generated (in %) in Finland in 2007 to that in 2008?
Provide a short and direct response. 1.01. What is the ratio of the Revenue generated (in %) in Uganda in 2007 to that in 2008?
Make the answer very short. 0.94. What is the ratio of the Revenue generated (in %) of Europe(developing only) in 2007 to that in 2009?
Keep it short and to the point. 1.05. What is the ratio of the Revenue generated (in %) in Bangladesh in 2007 to that in 2009?
Give a very brief answer. 0.98. What is the ratio of the Revenue generated (in %) of Finland in 2007 to that in 2009?
Make the answer very short. 0.93. What is the ratio of the Revenue generated (in %) in Uganda in 2007 to that in 2009?
Your answer should be very brief. 0.97. What is the ratio of the Revenue generated (in %) of Europe(developing only) in 2007 to that in 2010?
Offer a terse response. 1.04. What is the ratio of the Revenue generated (in %) of Bangladesh in 2007 to that in 2010?
Keep it short and to the point. 0.95. What is the ratio of the Revenue generated (in %) of Finland in 2007 to that in 2010?
Offer a terse response. 0.92. What is the ratio of the Revenue generated (in %) in Europe(developing only) in 2008 to that in 2009?
Provide a succinct answer. 1.03. What is the ratio of the Revenue generated (in %) of Bangladesh in 2008 to that in 2009?
Give a very brief answer. 0.96. What is the ratio of the Revenue generated (in %) in Finland in 2008 to that in 2009?
Keep it short and to the point. 0.92. What is the ratio of the Revenue generated (in %) in Uganda in 2008 to that in 2009?
Give a very brief answer. 1.03. What is the ratio of the Revenue generated (in %) of Europe(developing only) in 2008 to that in 2010?
Give a very brief answer. 1.02. What is the ratio of the Revenue generated (in %) of Bangladesh in 2008 to that in 2010?
Your answer should be very brief. 0.93. What is the ratio of the Revenue generated (in %) of Finland in 2008 to that in 2010?
Keep it short and to the point. 0.91. What is the ratio of the Revenue generated (in %) of Uganda in 2008 to that in 2010?
Your answer should be very brief. 1.06. What is the ratio of the Revenue generated (in %) of Europe(developing only) in 2009 to that in 2010?
Give a very brief answer. 0.99. What is the ratio of the Revenue generated (in %) in Bangladesh in 2009 to that in 2010?
Offer a very short reply. 0.97. What is the ratio of the Revenue generated (in %) of Finland in 2009 to that in 2010?
Offer a very short reply. 0.98. What is the ratio of the Revenue generated (in %) in Uganda in 2009 to that in 2010?
Provide a short and direct response. 1.03. What is the difference between the highest and the second highest Revenue generated (in %) in Europe(developing only)?
Make the answer very short. 0.18. What is the difference between the highest and the second highest Revenue generated (in %) of Bangladesh?
Your answer should be very brief. 0.79. What is the difference between the highest and the second highest Revenue generated (in %) in Finland?
Provide a succinct answer. 0.54. What is the difference between the highest and the second highest Revenue generated (in %) of Uganda?
Ensure brevity in your answer.  1.25. What is the difference between the highest and the lowest Revenue generated (in %) of Europe(developing only)?
Make the answer very short. 2.89. What is the difference between the highest and the lowest Revenue generated (in %) of Bangladesh?
Offer a very short reply. 2.13. What is the difference between the highest and the lowest Revenue generated (in %) in Finland?
Provide a short and direct response. 3.2. What is the difference between the highest and the lowest Revenue generated (in %) of Uganda?
Ensure brevity in your answer.  11.78. 